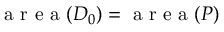Convert formula to latex. <formula><loc_0><loc_0><loc_500><loc_500>{ a r e a ( D _ { 0 } ) = a r e a ( P ) }</formula> 